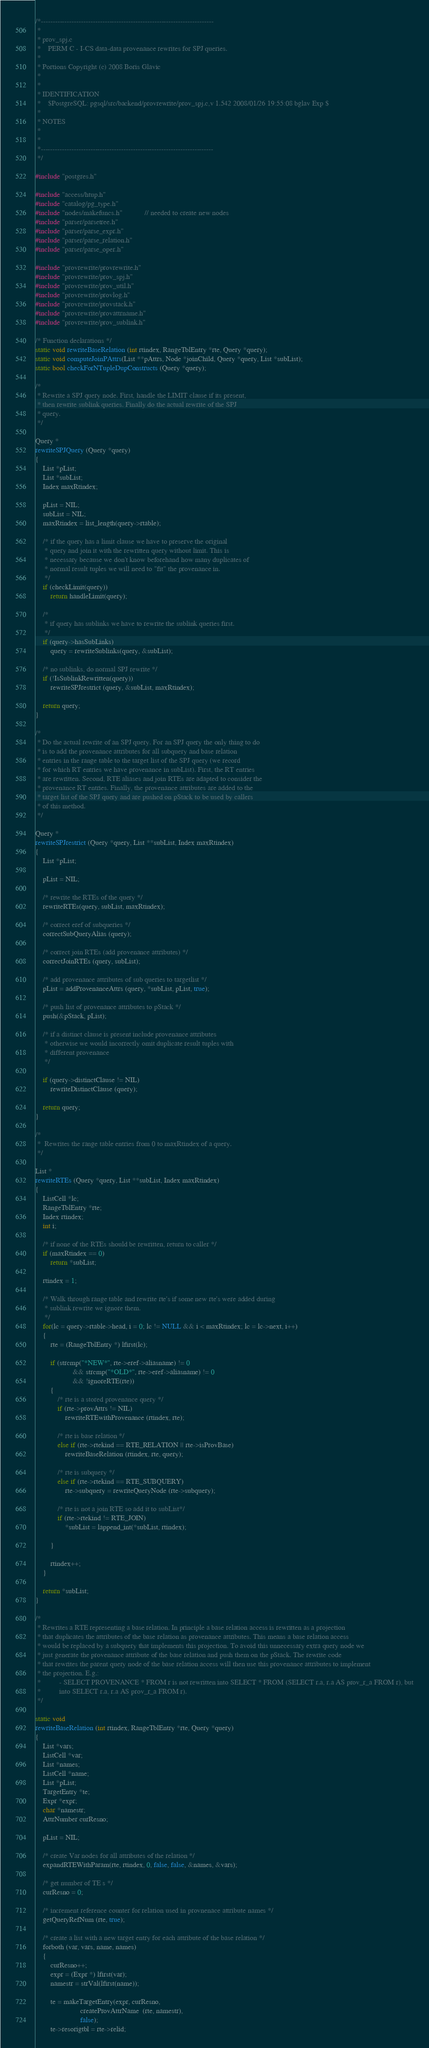Convert code to text. <code><loc_0><loc_0><loc_500><loc_500><_C_>/*-------------------------------------------------------------------------
 *
 * prov_spj.c
 *	  PERM C - I-CS data-data provenance rewrites for SPJ queries.
 *
 * Portions Copyright (c) 2008 Boris Glavic
 *
 *
 * IDENTIFICATION
 *	  $PostgreSQL: pgsql/src/backend/provrewrite/prov_spj.c,v 1.542 2008/01/26 19:55:08 bglav Exp $
 *
 * NOTES
 *
 *
 *-------------------------------------------------------------------------
 */

#include "postgres.h"

#include "access/htup.h"
#include "catalog/pg_type.h"
#include "nodes/makefuncs.h"			// needed to create new nodes
#include "parser/parsetree.h"
#include "parser/parse_expr.h"
#include "parser/parse_relation.h"
#include "parser/parse_oper.h"

#include "provrewrite/provrewrite.h"
#include "provrewrite/prov_spj.h"
#include "provrewrite/prov_util.h"
#include "provrewrite/provlog.h"
#include "provrewrite/provstack.h"
#include "provrewrite/provattrname.h"
#include "provrewrite/prov_sublink.h"

/* Function declarations */
static void rewriteBaseRelation (int rtindex, RangeTblEntry *rte, Query *query);
static void computeJoinPAttrs(List **pAttrs, Node *joinChild, Query *query, List *subList);
static bool checkForNTupleDupConstructs (Query *query);

/*
 * Rewrite a SPJ query node. First, handle the LIMIT clause if its present,
 * then rewrite sublink queries. Finally do the actual rewrite of the SPJ
 * query.
 */

Query *
rewriteSPJQuery (Query *query)
{
	List *pList;
	List *subList;
	Index maxRtindex;

	pList = NIL;
	subList = NIL;
	maxRtindex = list_length(query->rtable);

	/* if the query has a limit clause we have to preserve the original
	 * query and join it with the rewritten query without limit. This is
	 * necessary because we don't know beforehand how many duplicates of
	 * normal result tuples we will need to "fit" the provenance in.
	 */
	if (checkLimit(query))
		return handleLimit(query);

	/*
	 * if query has sublinks we have to rewrite the sublink queries first.
	 */
	if (query->hasSubLinks)
		query = rewriteSublinks(query, &subList);

	/* no sublinks, do normal SPJ rewrite */
	if (!IsSublinkRewritten(query))
		rewriteSPJrestrict (query, &subList, maxRtindex);

	return query;
}

/*
 * Do the actual rewrite of an SPJ query. For an SPJ query the only thing to do
 * is to add the provenance attributes for all subquery and base relation
 * entries in the range table to the target list of the SPJ query (we record
 * for which RT entries we have provenance in subList). First, the RT entries
 * are rewritten. Second, RTE aliases and join RTEs are adapted to consider the
 * provenance RT entries. Finally, the provenance attributes are added to the
 * target list of the SPJ query and are pushed on pStack to be used by callers
 * of this method.
 */

Query *
rewriteSPJrestrict (Query *query, List **subList, Index maxRtindex)
{
	List *pList;

	pList = NIL;

	/* rewrite the RTEs of the query */
	rewriteRTEs(query, subList, maxRtindex);

	/* correct eref of subqueries */
	correctSubQueryAlias (query);

	/* correct join RTEs (add provenance attributes) */
	correctJoinRTEs (query, subList);

	/* add provenance attributes of sub queries to targetlist */
	pList = addProvenanceAttrs (query, *subList, pList, true);

	/* push list of provenance attributes to pStack */
	push(&pStack, pList);

	/* if a distinct clause is present include provenance attributes
	 * otherwise we would incorrectly omit duplicate result tuples with
	 * different provenance
	 */

	if (query->distinctClause != NIL)
		rewriteDistinctClause (query);

	return query;
}

/*
 *	Rewrites the range table entries from 0 to maxRtindex of a query.
 */

List *
rewriteRTEs (Query *query, List **subList, Index maxRtindex)
{
	ListCell *lc;
	RangeTblEntry *rte;
	Index rtindex;
	int i;

	/* if none of the RTEs should be rewritten, return to caller */
	if (maxRtindex == 0)
		return *subList;

	rtindex = 1;

	/* Walk through range table and rewrite rte's if some new rte's were added during
	 * sublink rewrite we ignore them.
	 */
	for(lc = query->rtable->head, i = 0; lc != NULL && i < maxRtindex; lc = lc->next, i++)
	{
		rte = (RangeTblEntry *) lfirst(lc);

		if (strcmp("*NEW*", rte->eref->aliasname) != 0
					&& strcmp("*OLD*", rte->eref->aliasname) != 0
					&& !ignoreRTE(rte))
		{
			/* rte is a stored provenance query */
			if (rte->provAttrs != NIL)
				rewriteRTEwithProvenance (rtindex, rte);

			/* rte is base relation */
			else if (rte->rtekind == RTE_RELATION || rte->isProvBase)
				rewriteBaseRelation (rtindex, rte, query);

			/* rte is subquery */
			else if (rte->rtekind == RTE_SUBQUERY)
				rte->subquery = rewriteQueryNode (rte->subquery);

			/* rte is not a join RTE so add it to subList*/
			if (rte->rtekind != RTE_JOIN)
				*subList = lappend_int(*subList, rtindex);

		}

		rtindex++;
	}

	return *subList;
}

/*
 * Rewrites a RTE representing a base relation. In principle a base relation access is rewritten as a projection
 * that duplicates the attributes of the base relation as provenance attributes. This means a base relation access
 * would be replaced by a subquery that implements this projection. To avoid this unnecessary extra query node we
 * just generate the provenance attribute of the base relation and push them on the pStack. The rewrite code
 * that rewrites the parent query node of the base relation access will then use this provenance attributes to implement
 * the projection. E.g.:
 * 			- SELECT PROVENANCE * FROM r is not rewritten into SELECT * FROM (SELECT r.a, r.a AS prov_r_a FROM r), but
 * 			into SELECT r.a, r.a AS prov_r_a FROM r).
 */

static void
rewriteBaseRelation (int rtindex, RangeTblEntry *rte, Query *query)
{
	List *vars;
	ListCell *var;
	List *names;
	ListCell *name;
	List *pList;
	TargetEntry *te;
	Expr *expr;
	char *namestr;
	AttrNumber curResno;

	pList = NIL;

	/* create Var nodes for all attributes of the relation */
	expandRTEWithParam(rte, rtindex, 0, false, false, &names, &vars);

	/* get number of TE s */
	curResno = 0;

	/* increment reference counter for relation used in provnenace attribute names */
	getQueryRefNum (rte, true);

	/* create a list with a new target entry for each attribute of the base relation */
	forboth (var, vars, name, names)
	{
		curResno++;
		expr = (Expr *) lfirst(var);
		namestr = strVal(lfirst(name));

		te = makeTargetEntry(expr, curResno,
						createProvAttrName  (rte, namestr),
						false);
		te->resorigtbl = rte->relid;</code> 